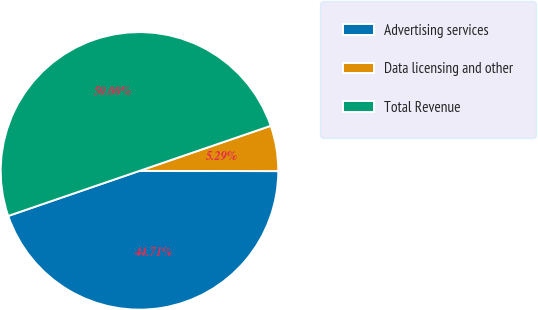Convert chart. <chart><loc_0><loc_0><loc_500><loc_500><pie_chart><fcel>Advertising services<fcel>Data licensing and other<fcel>Total Revenue<nl><fcel>44.71%<fcel>5.29%<fcel>50.0%<nl></chart> 